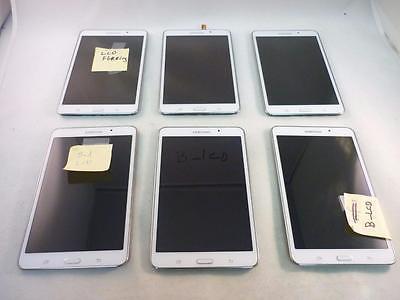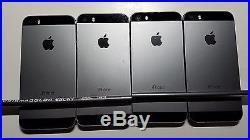The first image is the image on the left, the second image is the image on the right. Analyze the images presented: Is the assertion "The right image contains two horizontal rows of cell phones." valid? Answer yes or no. No. The first image is the image on the left, the second image is the image on the right. For the images shown, is this caption "Cell phones are lined in two lines on a surface in the image on the right." true? Answer yes or no. No. 